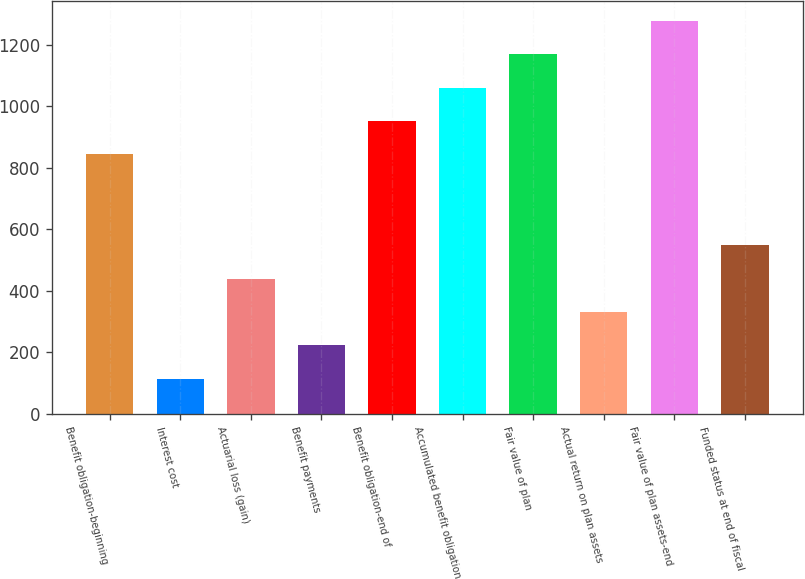Convert chart. <chart><loc_0><loc_0><loc_500><loc_500><bar_chart><fcel>Benefit obligation-beginning<fcel>Interest cost<fcel>Actuarial loss (gain)<fcel>Benefit payments<fcel>Benefit obligation-end of<fcel>Accumulated benefit obligation<fcel>Fair value of plan<fcel>Actual return on plan assets<fcel>Fair value of plan assets-end<fcel>Funded status at end of fiscal<nl><fcel>844<fcel>114.4<fcel>439.6<fcel>222.8<fcel>952.4<fcel>1060.8<fcel>1169.2<fcel>331.2<fcel>1277.6<fcel>548<nl></chart> 